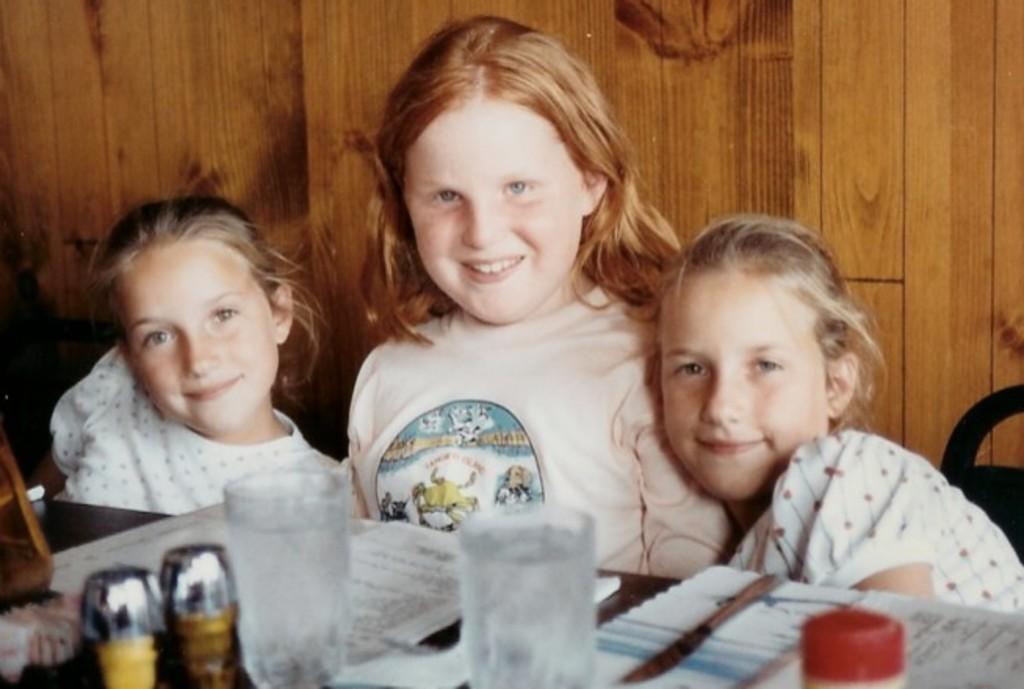Describe this image in one or two sentences. In this image I can see three persons sitting, I can also see few glasses, papers, bottles on the table. Background I can see the wooden wall. 